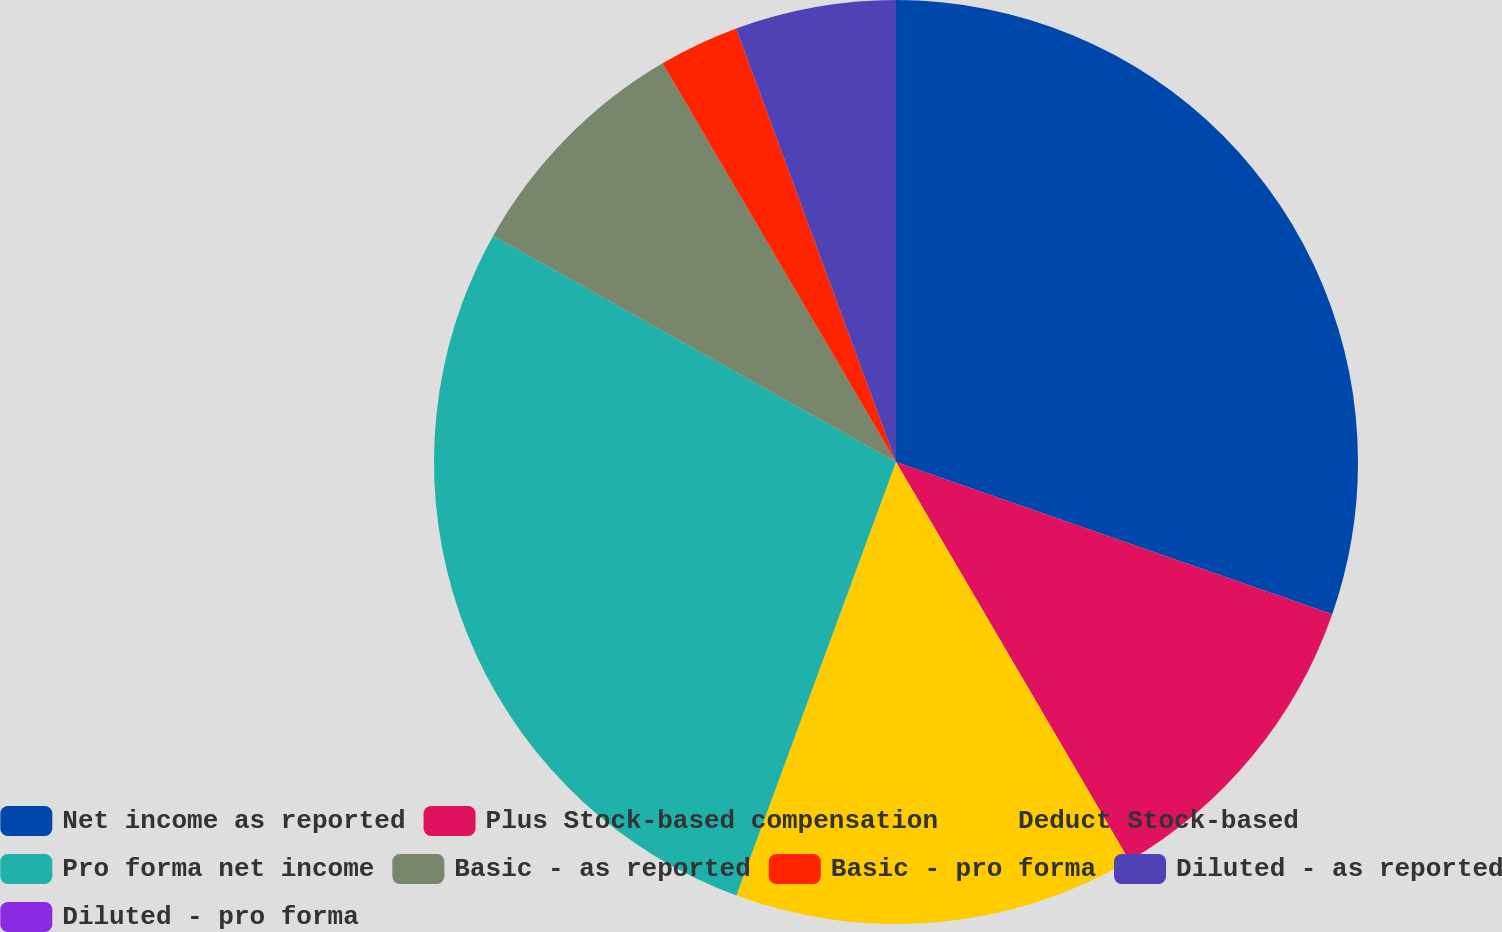Convert chart to OTSL. <chart><loc_0><loc_0><loc_500><loc_500><pie_chart><fcel>Net income as reported<fcel>Plus Stock-based compensation<fcel>Deduct Stock-based<fcel>Pro forma net income<fcel>Basic - as reported<fcel>Basic - pro forma<fcel>Diluted - as reported<fcel>Diluted - pro forma<nl><fcel>30.34%<fcel>11.23%<fcel>14.04%<fcel>27.53%<fcel>8.42%<fcel>2.81%<fcel>5.62%<fcel>0.0%<nl></chart> 